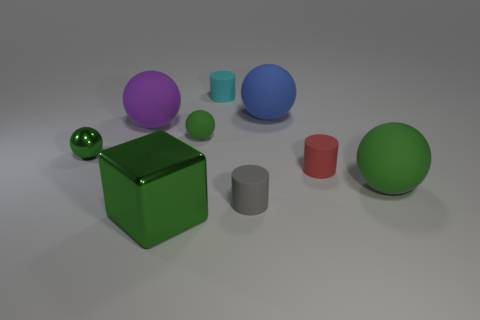Subtract all green balls. How many were subtracted if there are1green balls left? 2 Subtract all balls. How many objects are left? 4 Subtract all rubber spheres. How many spheres are left? 1 Subtract all cyan cylinders. How many cyan blocks are left? 0 Subtract all red cylinders. Subtract all red matte objects. How many objects are left? 7 Add 5 spheres. How many spheres are left? 10 Add 6 large purple rubber balls. How many large purple rubber balls exist? 7 Subtract all blue spheres. How many spheres are left? 4 Subtract 1 cyan cylinders. How many objects are left? 8 Subtract 2 balls. How many balls are left? 3 